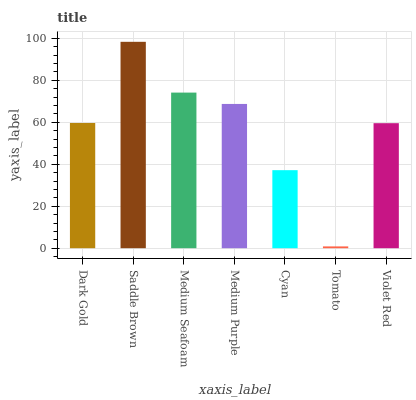Is Tomato the minimum?
Answer yes or no. Yes. Is Saddle Brown the maximum?
Answer yes or no. Yes. Is Medium Seafoam the minimum?
Answer yes or no. No. Is Medium Seafoam the maximum?
Answer yes or no. No. Is Saddle Brown greater than Medium Seafoam?
Answer yes or no. Yes. Is Medium Seafoam less than Saddle Brown?
Answer yes or no. Yes. Is Medium Seafoam greater than Saddle Brown?
Answer yes or no. No. Is Saddle Brown less than Medium Seafoam?
Answer yes or no. No. Is Dark Gold the high median?
Answer yes or no. Yes. Is Dark Gold the low median?
Answer yes or no. Yes. Is Tomato the high median?
Answer yes or no. No. Is Medium Purple the low median?
Answer yes or no. No. 